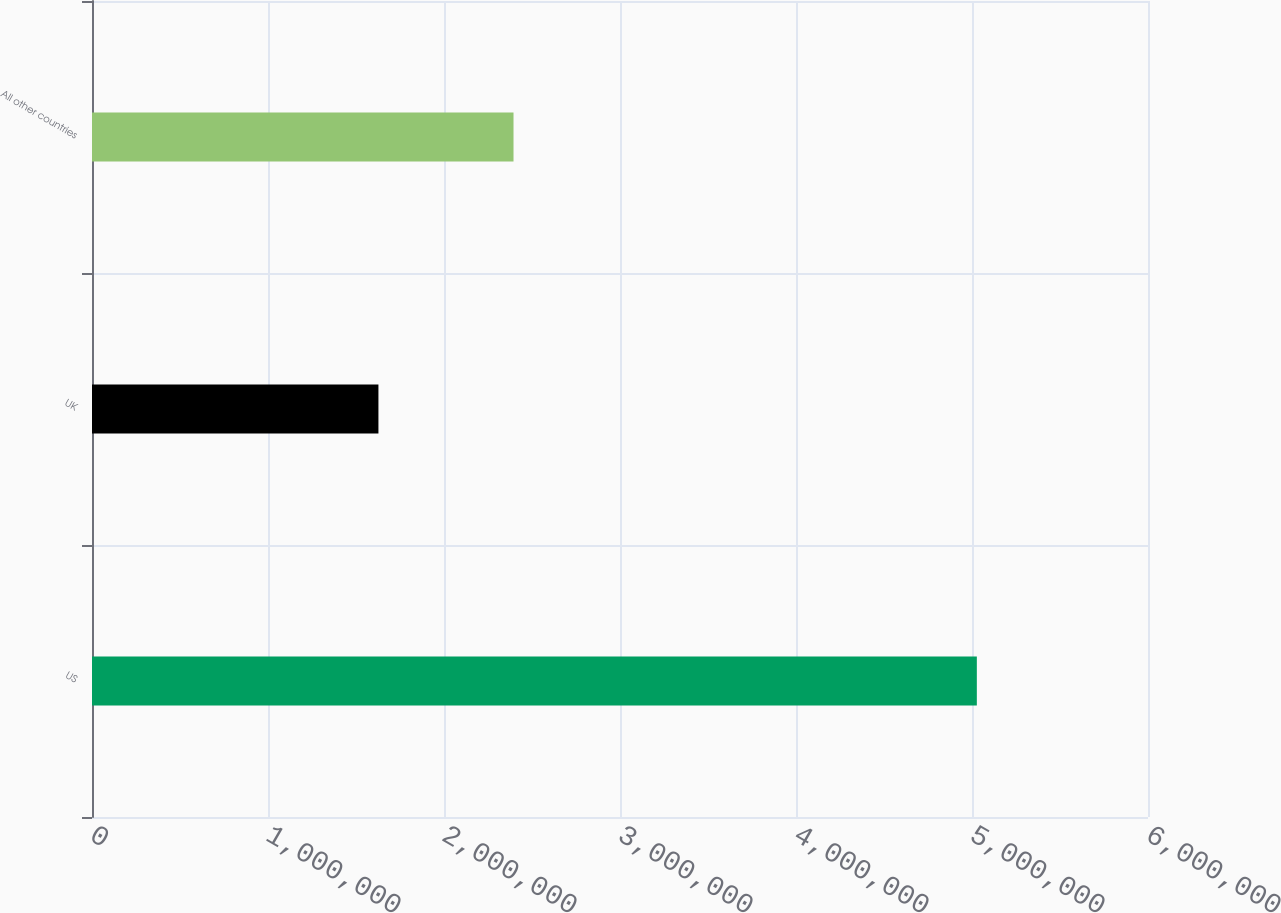<chart> <loc_0><loc_0><loc_500><loc_500><bar_chart><fcel>US<fcel>UK<fcel>All other countries<nl><fcel>5.02748e+06<fcel>1.62744e+06<fcel>2.39499e+06<nl></chart> 